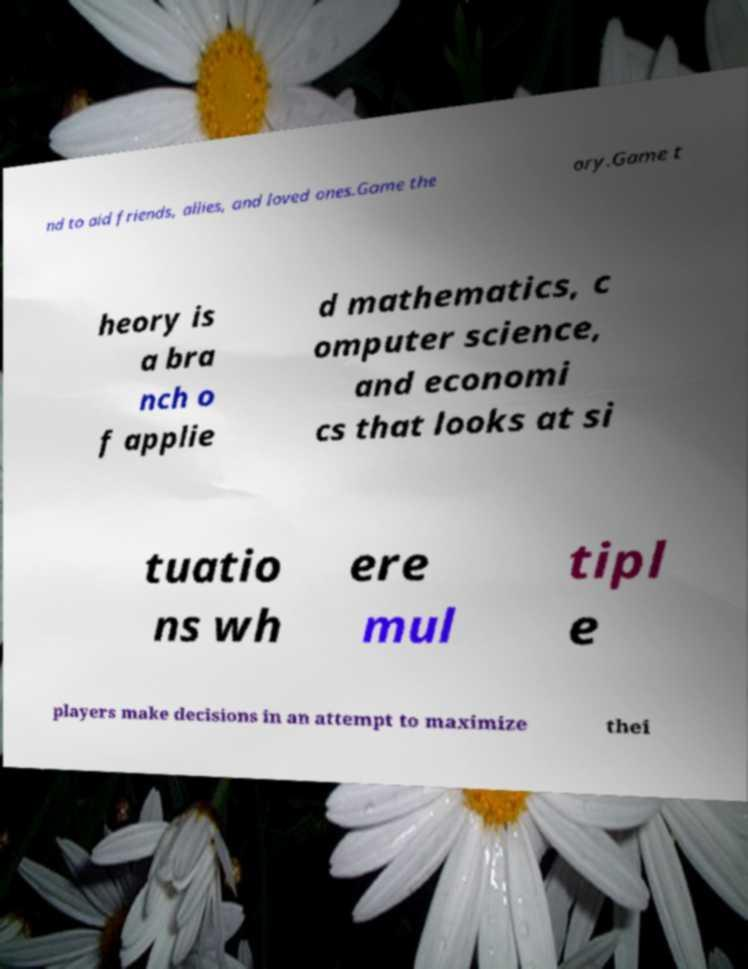Could you assist in decoding the text presented in this image and type it out clearly? nd to aid friends, allies, and loved ones.Game the ory.Game t heory is a bra nch o f applie d mathematics, c omputer science, and economi cs that looks at si tuatio ns wh ere mul tipl e players make decisions in an attempt to maximize thei 